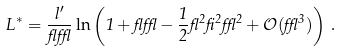Convert formula to latex. <formula><loc_0><loc_0><loc_500><loc_500>L ^ { * } = \frac { l ^ { \prime } } { \gamma \epsilon } \ln \left ( 1 + \gamma \epsilon - \frac { 1 } { 2 } \gamma ^ { 2 } \beta ^ { 2 } \epsilon ^ { 2 } + \mathcal { O } ( \epsilon ^ { 3 } ) \right ) \, .</formula> 